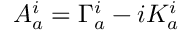<formula> <loc_0><loc_0><loc_500><loc_500>A _ { a } ^ { i } = \Gamma _ { a } ^ { i } - i K _ { a } ^ { i }</formula> 